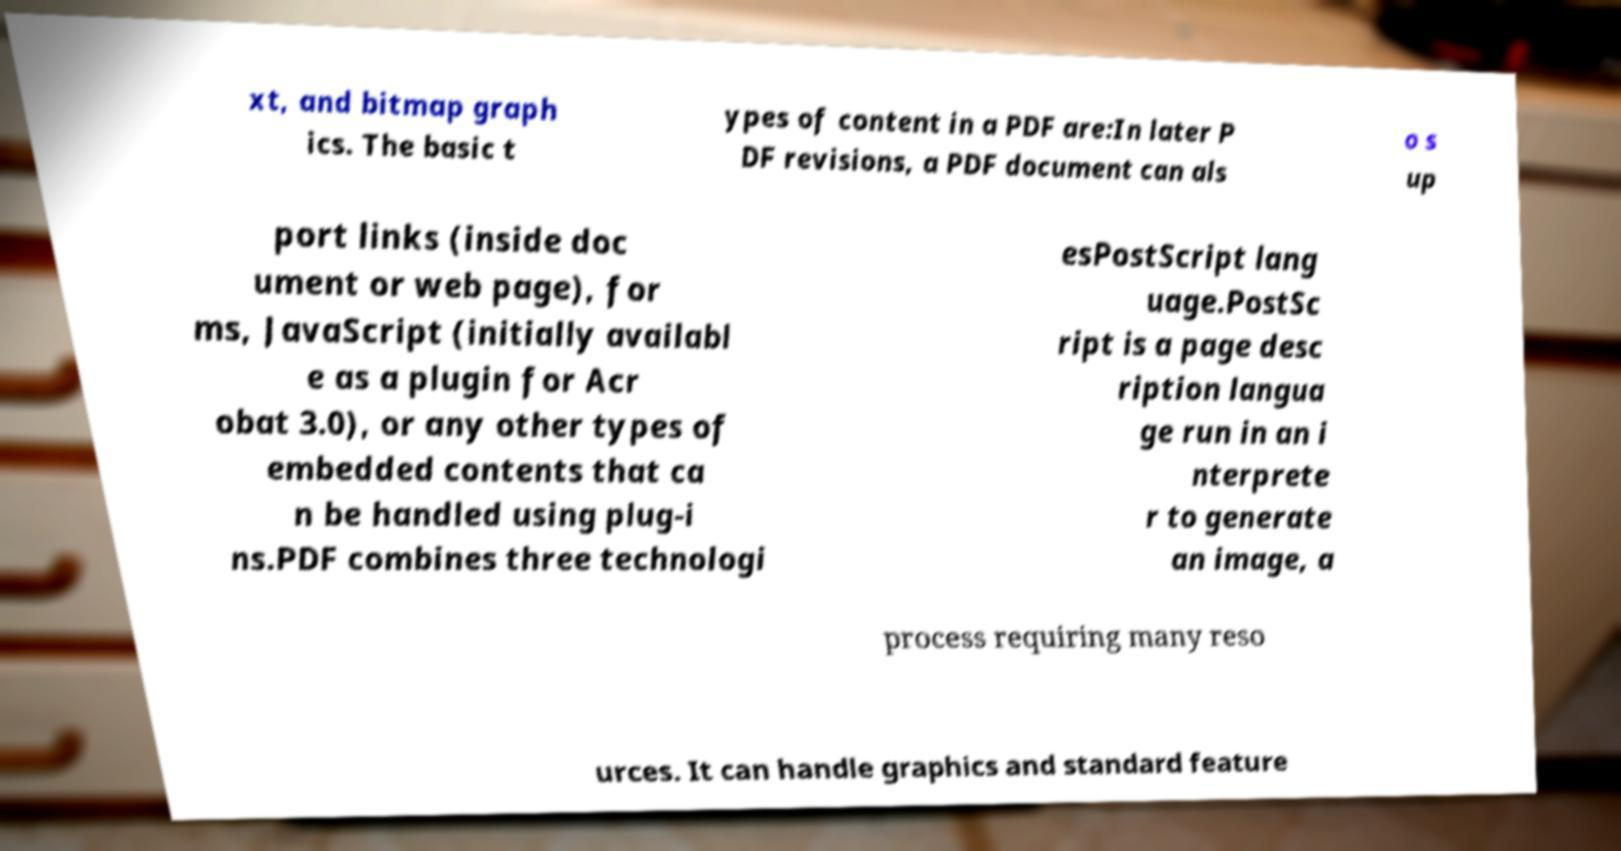Could you extract and type out the text from this image? xt, and bitmap graph ics. The basic t ypes of content in a PDF are:In later P DF revisions, a PDF document can als o s up port links (inside doc ument or web page), for ms, JavaScript (initially availabl e as a plugin for Acr obat 3.0), or any other types of embedded contents that ca n be handled using plug-i ns.PDF combines three technologi esPostScript lang uage.PostSc ript is a page desc ription langua ge run in an i nterprete r to generate an image, a process requiring many reso urces. It can handle graphics and standard feature 